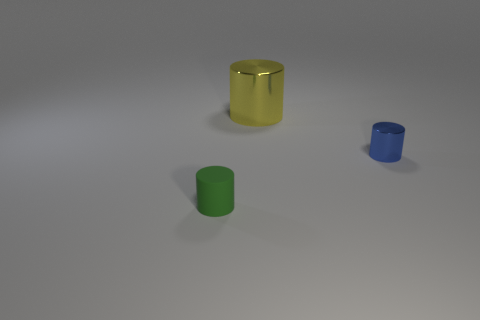Is there anything else that is made of the same material as the small green cylinder?
Offer a very short reply. No. Are there any other things that are the same size as the yellow shiny cylinder?
Keep it short and to the point. No. The cylinder that is both left of the tiny metallic thing and in front of the large cylinder is what color?
Make the answer very short. Green. Do the small object that is left of the big yellow thing and the yellow thing have the same material?
Provide a short and direct response. No. Are there fewer blue shiny cylinders left of the yellow shiny cylinder than gray shiny cylinders?
Give a very brief answer. No. Is there a green object made of the same material as the blue cylinder?
Provide a short and direct response. No. There is a blue shiny object; does it have the same size as the object that is in front of the tiny metallic thing?
Provide a short and direct response. Yes. Do the yellow cylinder and the green cylinder have the same material?
Provide a succinct answer. No. What number of small shiny cylinders are behind the large yellow metallic cylinder?
Provide a succinct answer. 0. There is a object that is right of the small rubber cylinder and in front of the big thing; what material is it?
Keep it short and to the point. Metal. 